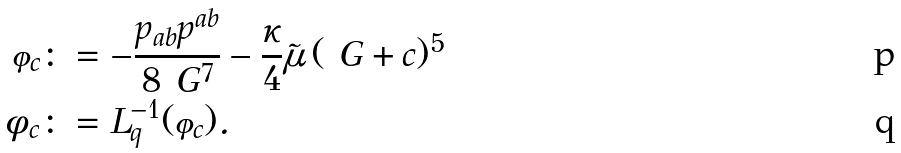Convert formula to latex. <formula><loc_0><loc_0><loc_500><loc_500>\varphi _ { c } & \colon = - \frac { p _ { a b } p ^ { a b } } { 8 \ G ^ { 7 } } - \frac { \kappa } { 4 } \tilde { \mu } \, ( \ G + c ) ^ { 5 } \\ \phi _ { c } & \colon = L _ { q } ^ { - 1 } ( \varphi _ { c } ) .</formula> 